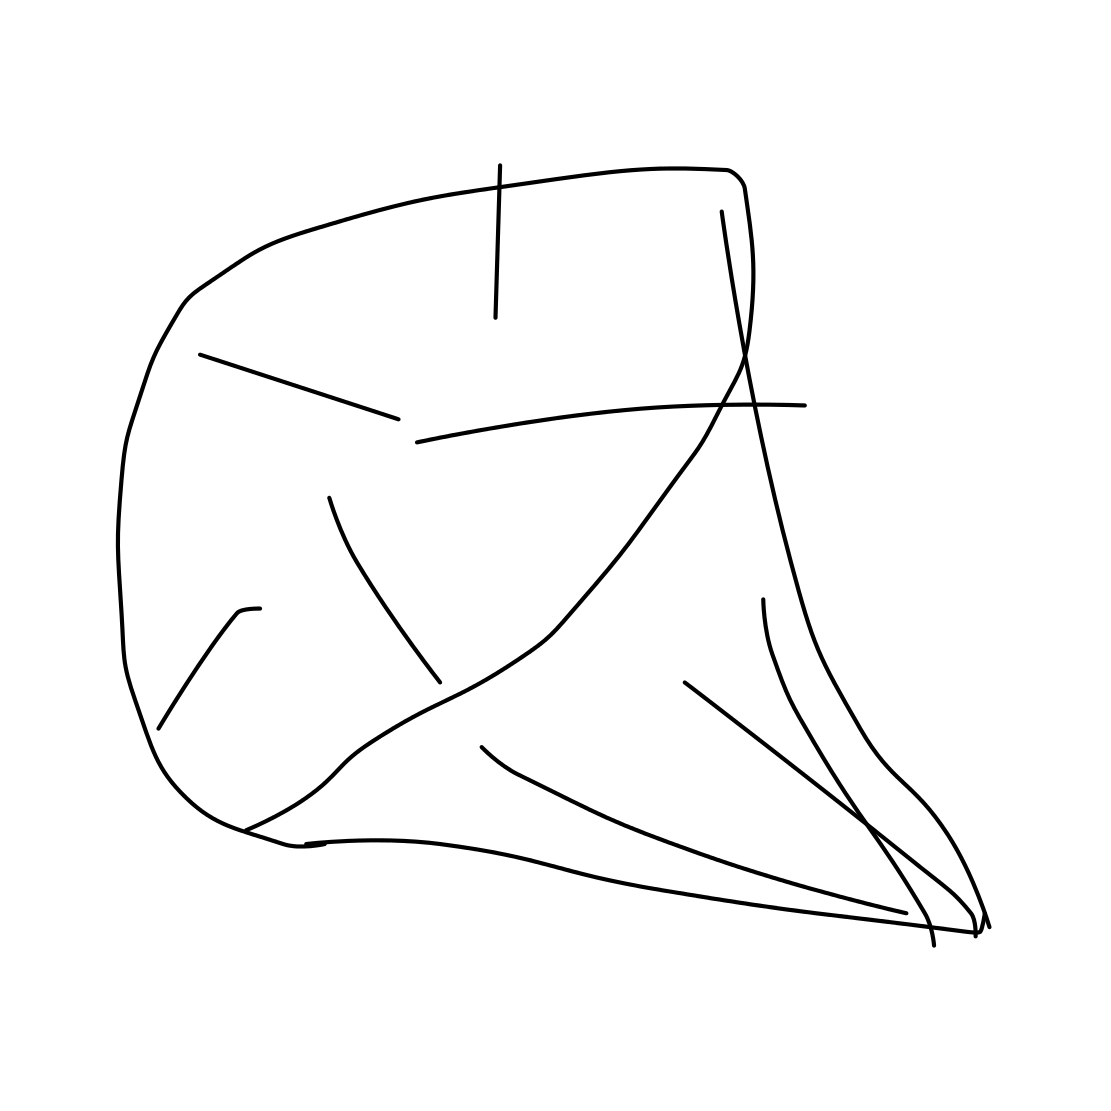Could this image be interpreted as a symbol, and if so, what could it represent? While the image is abstract, it's possible to interpret it as a symbol depending on one's perspective. For example, it could be seen as a representation of change or chaos due to its irregular structure, or it might symbolize a conceptual object open to individual interpretation. 